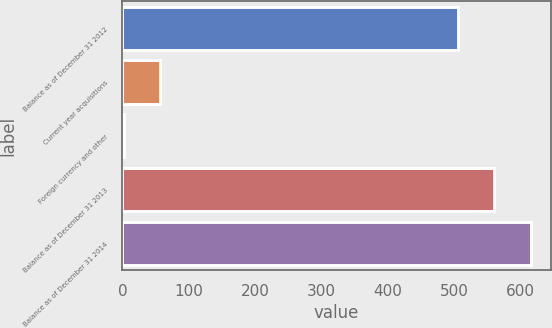Convert chart. <chart><loc_0><loc_0><loc_500><loc_500><bar_chart><fcel>Balance as of December 31 2012<fcel>Current year acquisitions<fcel>Foreign currency and other<fcel>Balance as of December 31 2013<fcel>Balance as of December 31 2014<nl><fcel>506<fcel>57.36<fcel>2.8<fcel>560.56<fcel>615.12<nl></chart> 